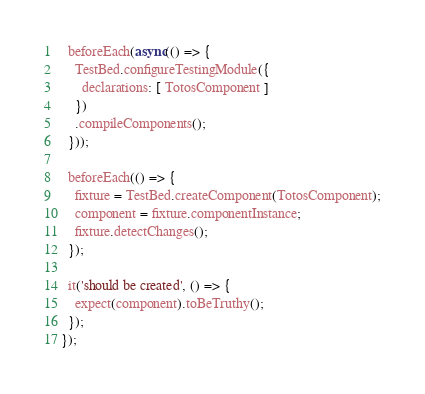Convert code to text. <code><loc_0><loc_0><loc_500><loc_500><_TypeScript_>  beforeEach(async(() => {
    TestBed.configureTestingModule({
      declarations: [ TotosComponent ]
    })
    .compileComponents();
  }));

  beforeEach(() => {
    fixture = TestBed.createComponent(TotosComponent);
    component = fixture.componentInstance;
    fixture.detectChanges();
  });

  it('should be created', () => {
    expect(component).toBeTruthy();
  });
});
</code> 